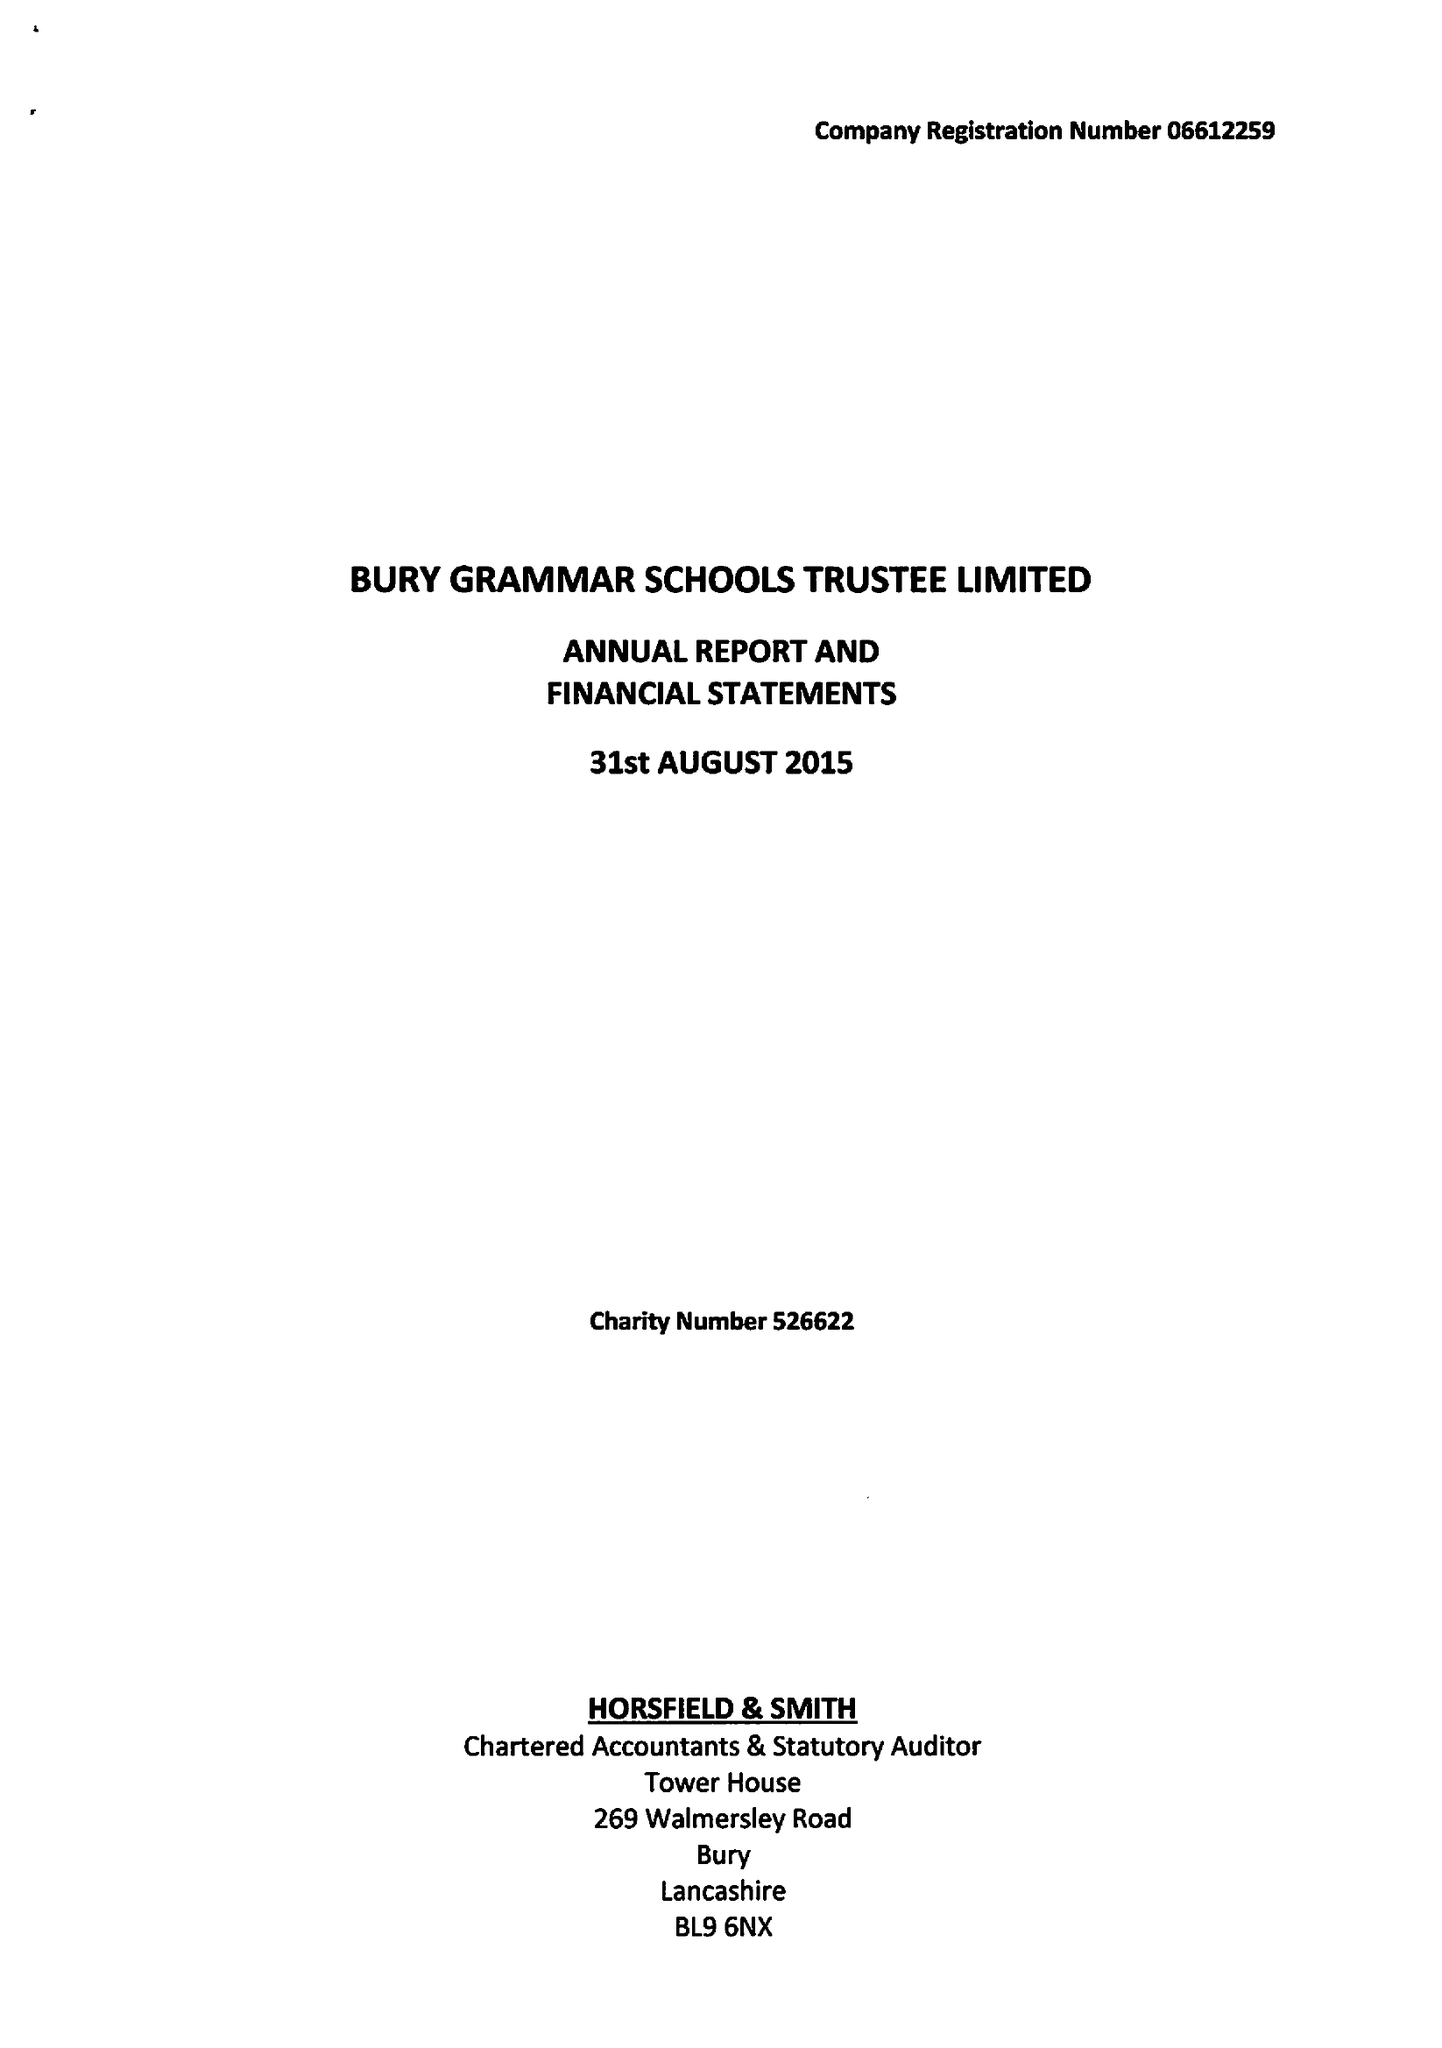What is the value for the address__post_town?
Answer the question using a single word or phrase. BURY 